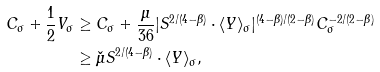<formula> <loc_0><loc_0><loc_500><loc_500>C _ { \sigma } + \frac { 1 } { 2 } V _ { \sigma } & \geq C _ { \sigma } + \frac { \mu } { 3 6 } | S ^ { 2 / ( 4 - \beta ) } \cdot \langle Y \rangle _ { \sigma } | ^ { ( 4 - \beta ) / ( 2 - \beta ) } C _ { \sigma } ^ { - 2 / ( 2 - \beta ) } \\ & \geq \check { \mu } S ^ { 2 / ( 4 - \beta ) } \cdot \langle Y \rangle _ { \sigma } ,</formula> 